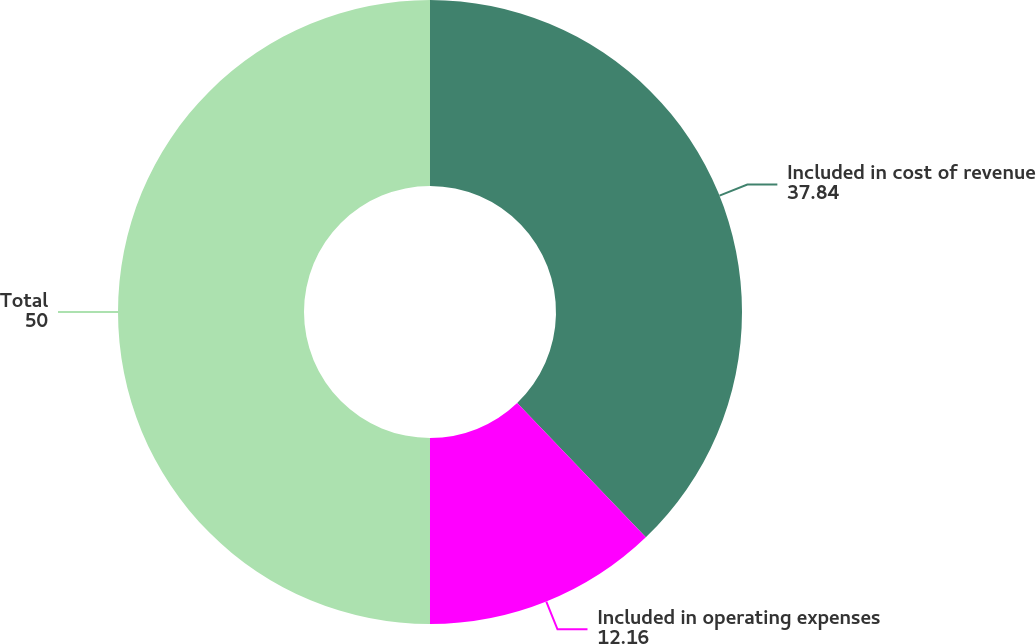Convert chart. <chart><loc_0><loc_0><loc_500><loc_500><pie_chart><fcel>Included in cost of revenue<fcel>Included in operating expenses<fcel>Total<nl><fcel>37.84%<fcel>12.16%<fcel>50.0%<nl></chart> 